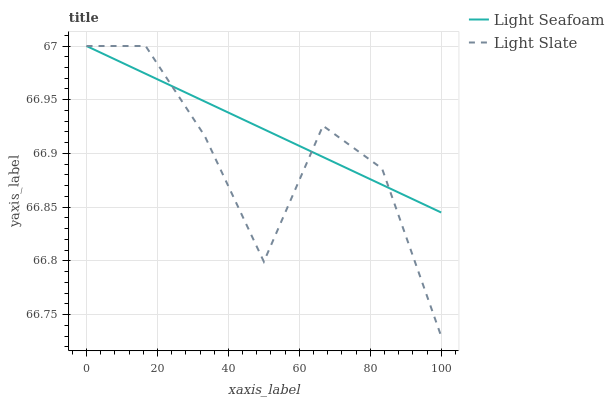Does Light Slate have the minimum area under the curve?
Answer yes or no. Yes. Does Light Seafoam have the maximum area under the curve?
Answer yes or no. Yes. Does Light Seafoam have the minimum area under the curve?
Answer yes or no. No. Is Light Seafoam the smoothest?
Answer yes or no. Yes. Is Light Slate the roughest?
Answer yes or no. Yes. Is Light Seafoam the roughest?
Answer yes or no. No. Does Light Slate have the lowest value?
Answer yes or no. Yes. Does Light Seafoam have the lowest value?
Answer yes or no. No. Does Light Seafoam have the highest value?
Answer yes or no. Yes. Does Light Slate intersect Light Seafoam?
Answer yes or no. Yes. Is Light Slate less than Light Seafoam?
Answer yes or no. No. Is Light Slate greater than Light Seafoam?
Answer yes or no. No. 